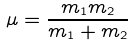Convert formula to latex. <formula><loc_0><loc_0><loc_500><loc_500>\mu = \frac { m _ { 1 } m _ { 2 } } { m _ { 1 } + m _ { 2 } }</formula> 